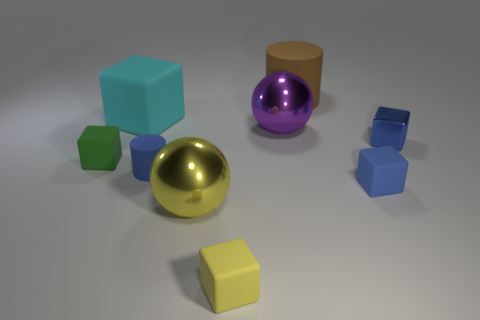Are there the same number of matte things in front of the big yellow metal object and balls that are in front of the tiny blue matte cylinder?
Provide a short and direct response. Yes. Do the ball that is in front of the purple metallic sphere and the rubber cylinder to the right of the yellow block have the same size?
Give a very brief answer. Yes. What material is the big thing that is on the left side of the large purple ball and in front of the big cyan rubber object?
Offer a very short reply. Metal. Is the number of green matte objects less than the number of blue rubber things?
Keep it short and to the point. Yes. There is a cylinder that is on the right side of the large thing in front of the blue rubber cylinder; how big is it?
Keep it short and to the point. Large. There is a metallic thing that is in front of the tiny blue matte thing that is left of the shiny sphere behind the small green cube; what is its shape?
Make the answer very short. Sphere. The big thing that is made of the same material as the large cylinder is what color?
Offer a terse response. Cyan. What color is the big shiny ball that is on the left side of the thing that is in front of the ball that is in front of the green matte block?
Offer a very short reply. Yellow. What number of balls are either tiny green matte things or large yellow metallic things?
Your answer should be compact. 1. There is a metal cube; does it have the same color as the large matte object that is left of the brown object?
Ensure brevity in your answer.  No. 